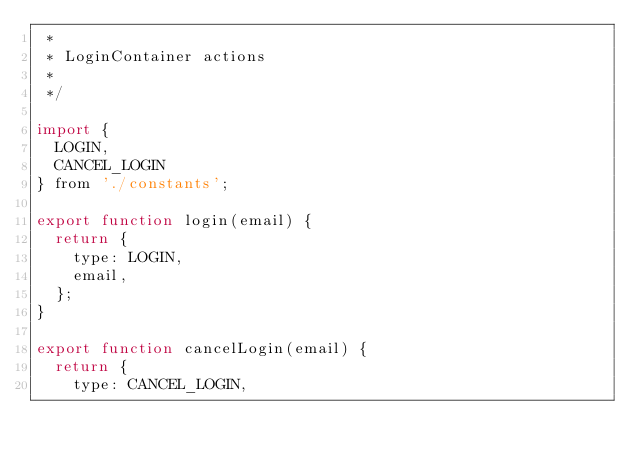<code> <loc_0><loc_0><loc_500><loc_500><_JavaScript_> *
 * LoginContainer actions
 *
 */

import {
  LOGIN,
  CANCEL_LOGIN
} from './constants';

export function login(email) {
  return {
    type: LOGIN,
    email,
  };
}

export function cancelLogin(email) {
  return {
    type: CANCEL_LOGIN,</code> 